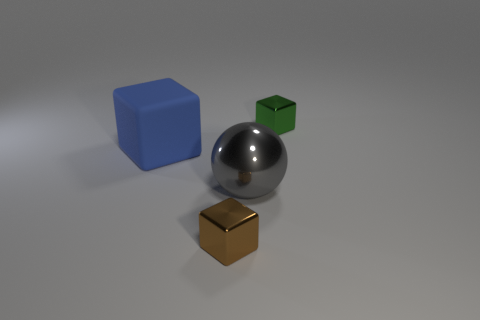Subtract all small metallic cubes. How many cubes are left? 1 Subtract all blocks. How many objects are left? 1 Subtract all green blocks. How many blocks are left? 2 Subtract 0 brown cylinders. How many objects are left? 4 Subtract 1 balls. How many balls are left? 0 Subtract all yellow blocks. Subtract all gray spheres. How many blocks are left? 3 Subtract all green blocks. How many green balls are left? 0 Subtract all big blue rubber blocks. Subtract all blue blocks. How many objects are left? 2 Add 1 blue matte things. How many blue matte things are left? 2 Add 4 large metallic things. How many large metallic things exist? 5 